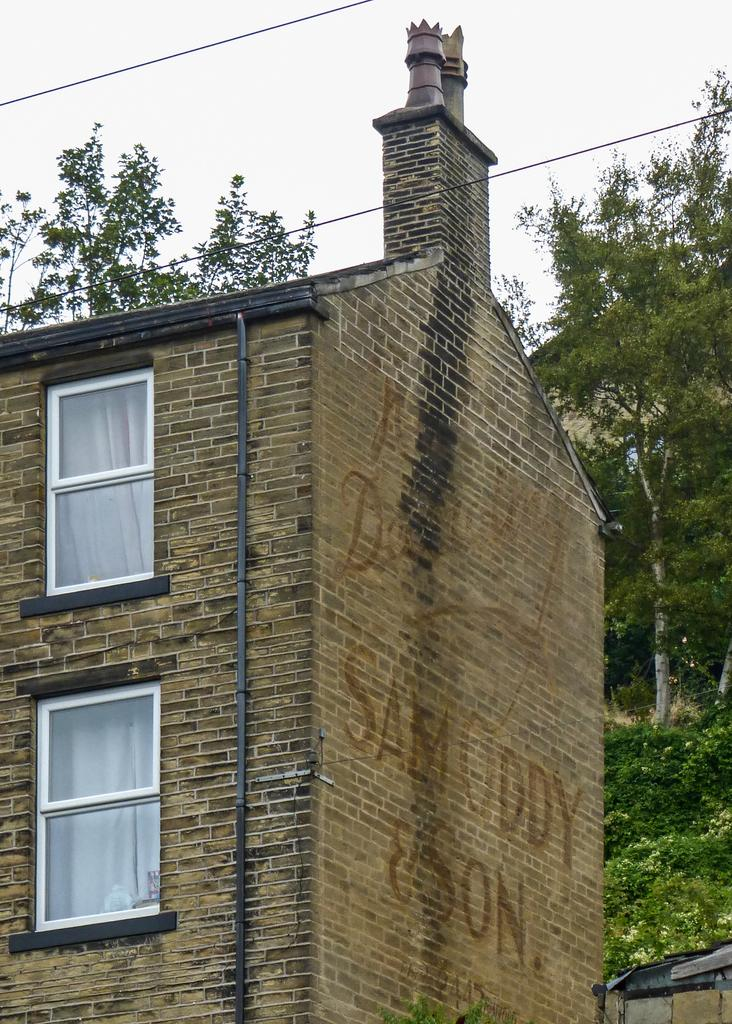What type of natural elements can be seen in the image? There are trees in the image. What man-made structures are present in the image? There is a building in the image. What type of infrastructure is visible in the image? Cables are present in the image. What architectural feature can be seen on the building? A pipe is visible on the building. What type of window treatment is present in the building? Curtains are present in the building. Can you see any dinosaurs roaming around near the trees in the image? No, there are no dinosaurs present in the image. What type of transportation is available at the airport depicted in the image? There is no airport depicted in the image. Is there a bed visible in the building in the image? No, there is no bed visible in the building in the image. 